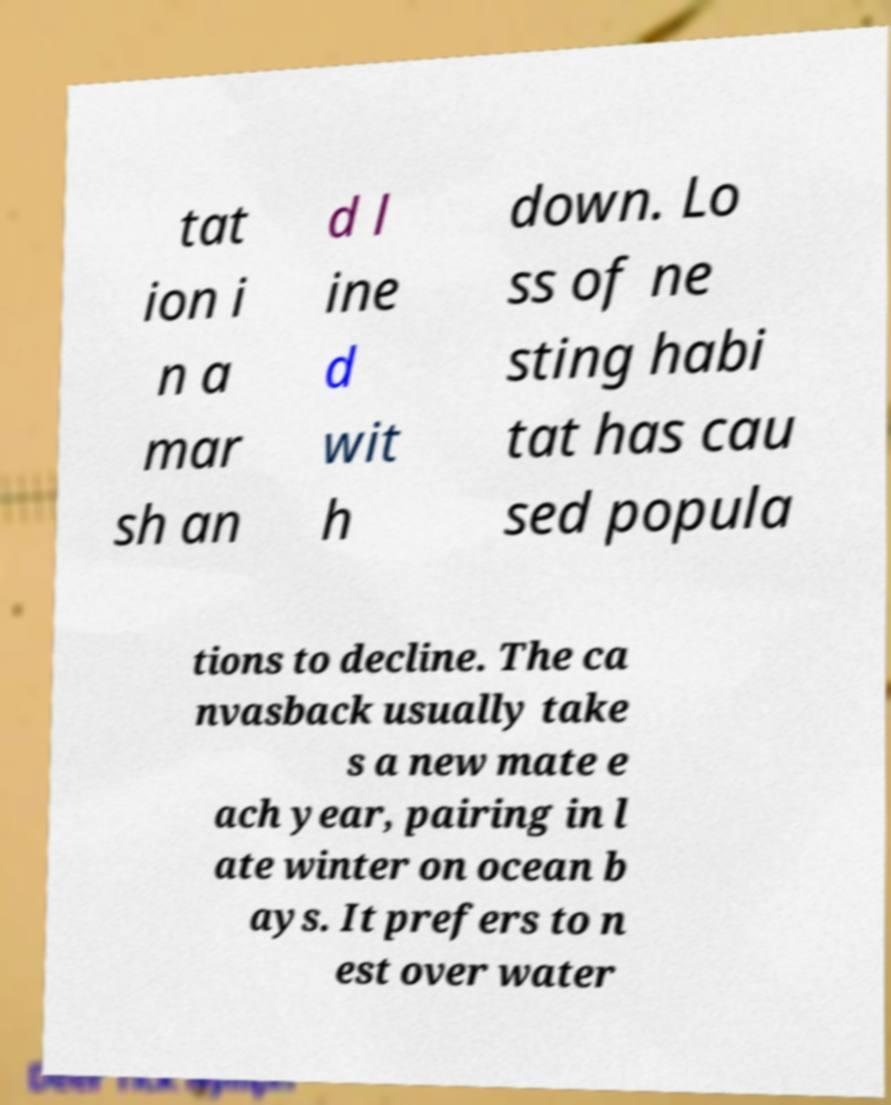Please read and relay the text visible in this image. What does it say? tat ion i n a mar sh an d l ine d wit h down. Lo ss of ne sting habi tat has cau sed popula tions to decline. The ca nvasback usually take s a new mate e ach year, pairing in l ate winter on ocean b ays. It prefers to n est over water 